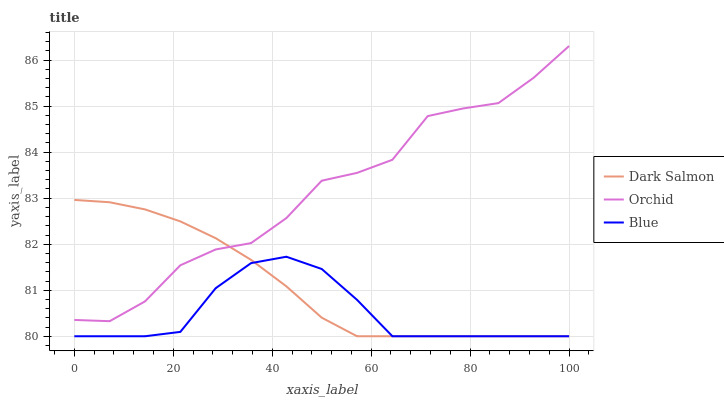Does Blue have the minimum area under the curve?
Answer yes or no. Yes. Does Orchid have the maximum area under the curve?
Answer yes or no. Yes. Does Dark Salmon have the minimum area under the curve?
Answer yes or no. No. Does Dark Salmon have the maximum area under the curve?
Answer yes or no. No. Is Dark Salmon the smoothest?
Answer yes or no. Yes. Is Orchid the roughest?
Answer yes or no. Yes. Is Orchid the smoothest?
Answer yes or no. No. Is Dark Salmon the roughest?
Answer yes or no. No. Does Blue have the lowest value?
Answer yes or no. Yes. Does Orchid have the lowest value?
Answer yes or no. No. Does Orchid have the highest value?
Answer yes or no. Yes. Does Dark Salmon have the highest value?
Answer yes or no. No. Is Blue less than Orchid?
Answer yes or no. Yes. Is Orchid greater than Blue?
Answer yes or no. Yes. Does Orchid intersect Dark Salmon?
Answer yes or no. Yes. Is Orchid less than Dark Salmon?
Answer yes or no. No. Is Orchid greater than Dark Salmon?
Answer yes or no. No. Does Blue intersect Orchid?
Answer yes or no. No. 